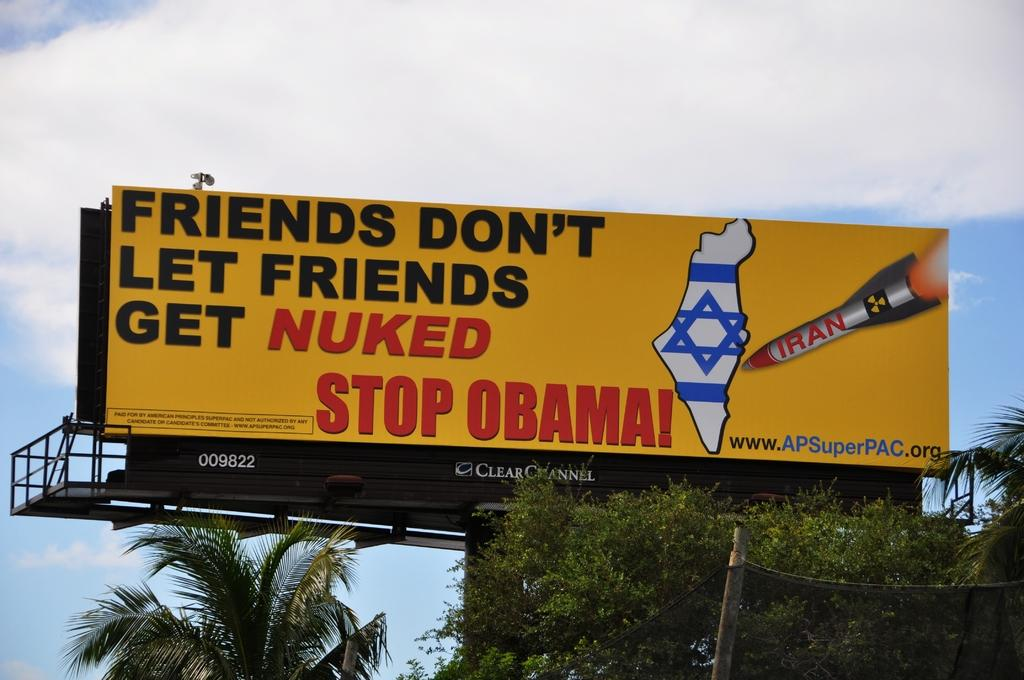<image>
Describe the image concisely. A large freeway billboard that says Friends Don't let friends get nuked stop obama 